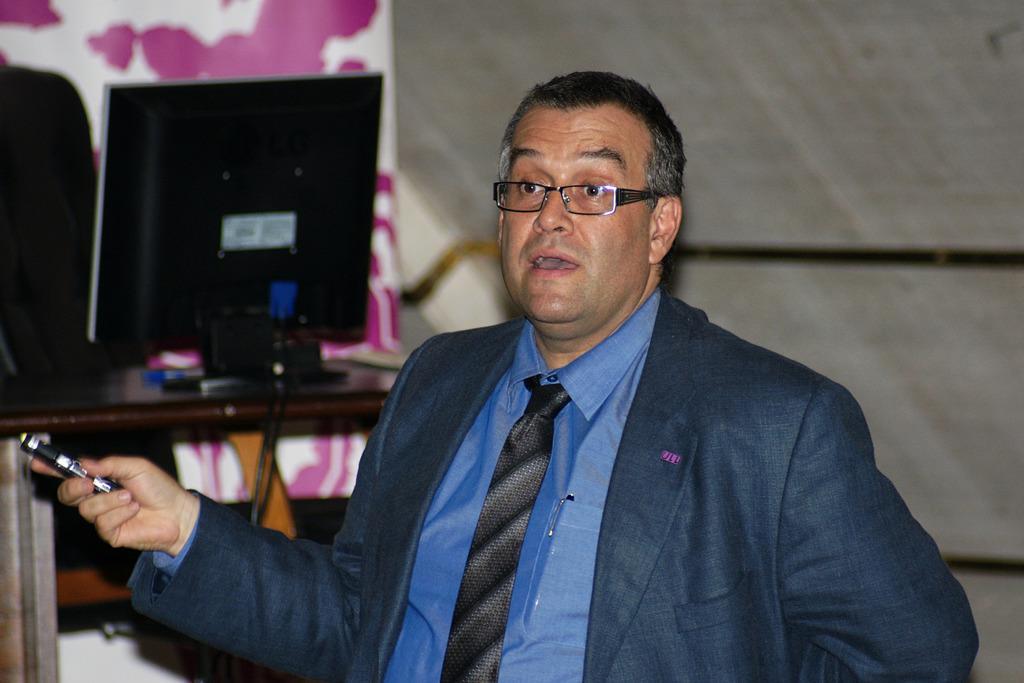In one or two sentences, can you explain what this image depicts? In this image in the foreground there is one person who is holding some pen and talking, and in the background there is a computer. On the table and there is a curtain, and a wall and some objects. 